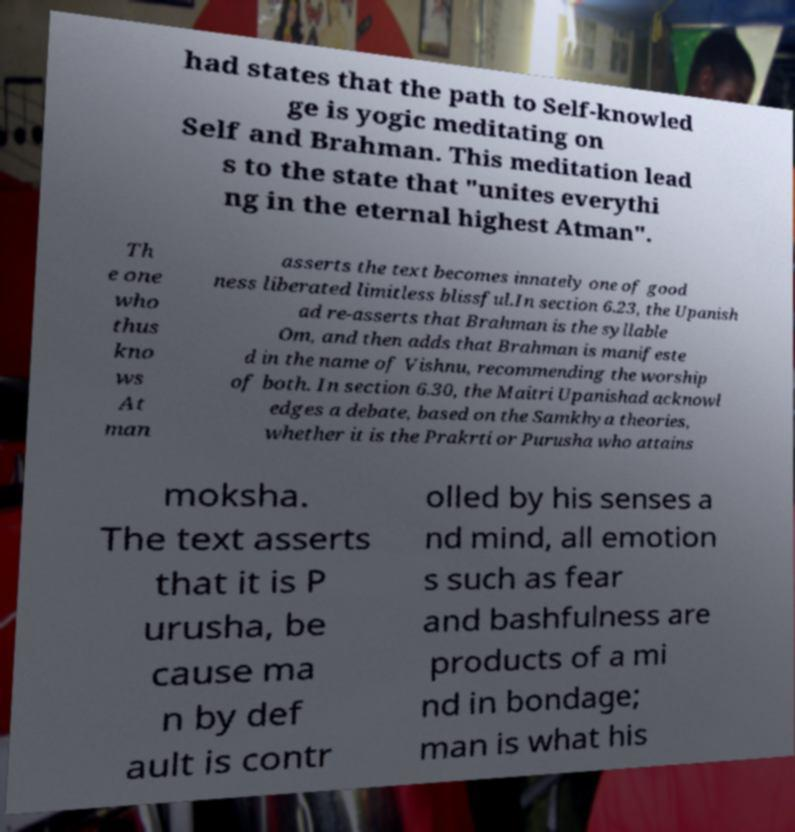Can you read and provide the text displayed in the image?This photo seems to have some interesting text. Can you extract and type it out for me? had states that the path to Self-knowled ge is yogic meditating on Self and Brahman. This meditation lead s to the state that "unites everythi ng in the eternal highest Atman". Th e one who thus kno ws At man asserts the text becomes innately one of good ness liberated limitless blissful.In section 6.23, the Upanish ad re-asserts that Brahman is the syllable Om, and then adds that Brahman is manifeste d in the name of Vishnu, recommending the worship of both. In section 6.30, the Maitri Upanishad acknowl edges a debate, based on the Samkhya theories, whether it is the Prakrti or Purusha who attains moksha. The text asserts that it is P urusha, be cause ma n by def ault is contr olled by his senses a nd mind, all emotion s such as fear and bashfulness are products of a mi nd in bondage; man is what his 